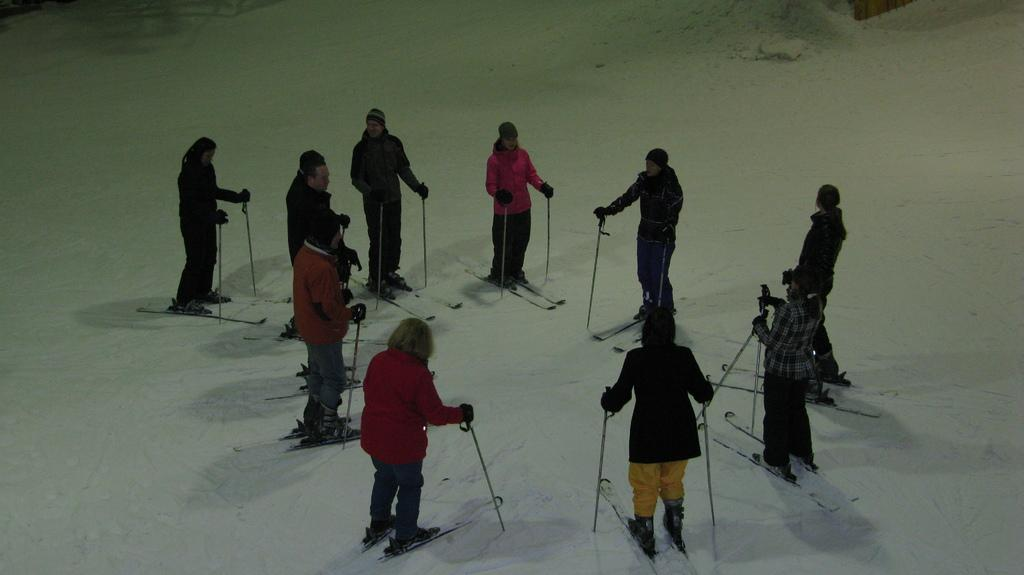How many people are in the image? There are persons in the image, but the exact number is not specified. Where are the persons located in the image? The persons are standing in the sky. How are the persons positioned in relation to each other? The persons are surrounding each other. What is the environment like in the image? The setting is on a snow land. What type of cookware can be seen in the image? There is no cookware present in the image. How many crates are visible in the image? There is no mention of crates in the image. 